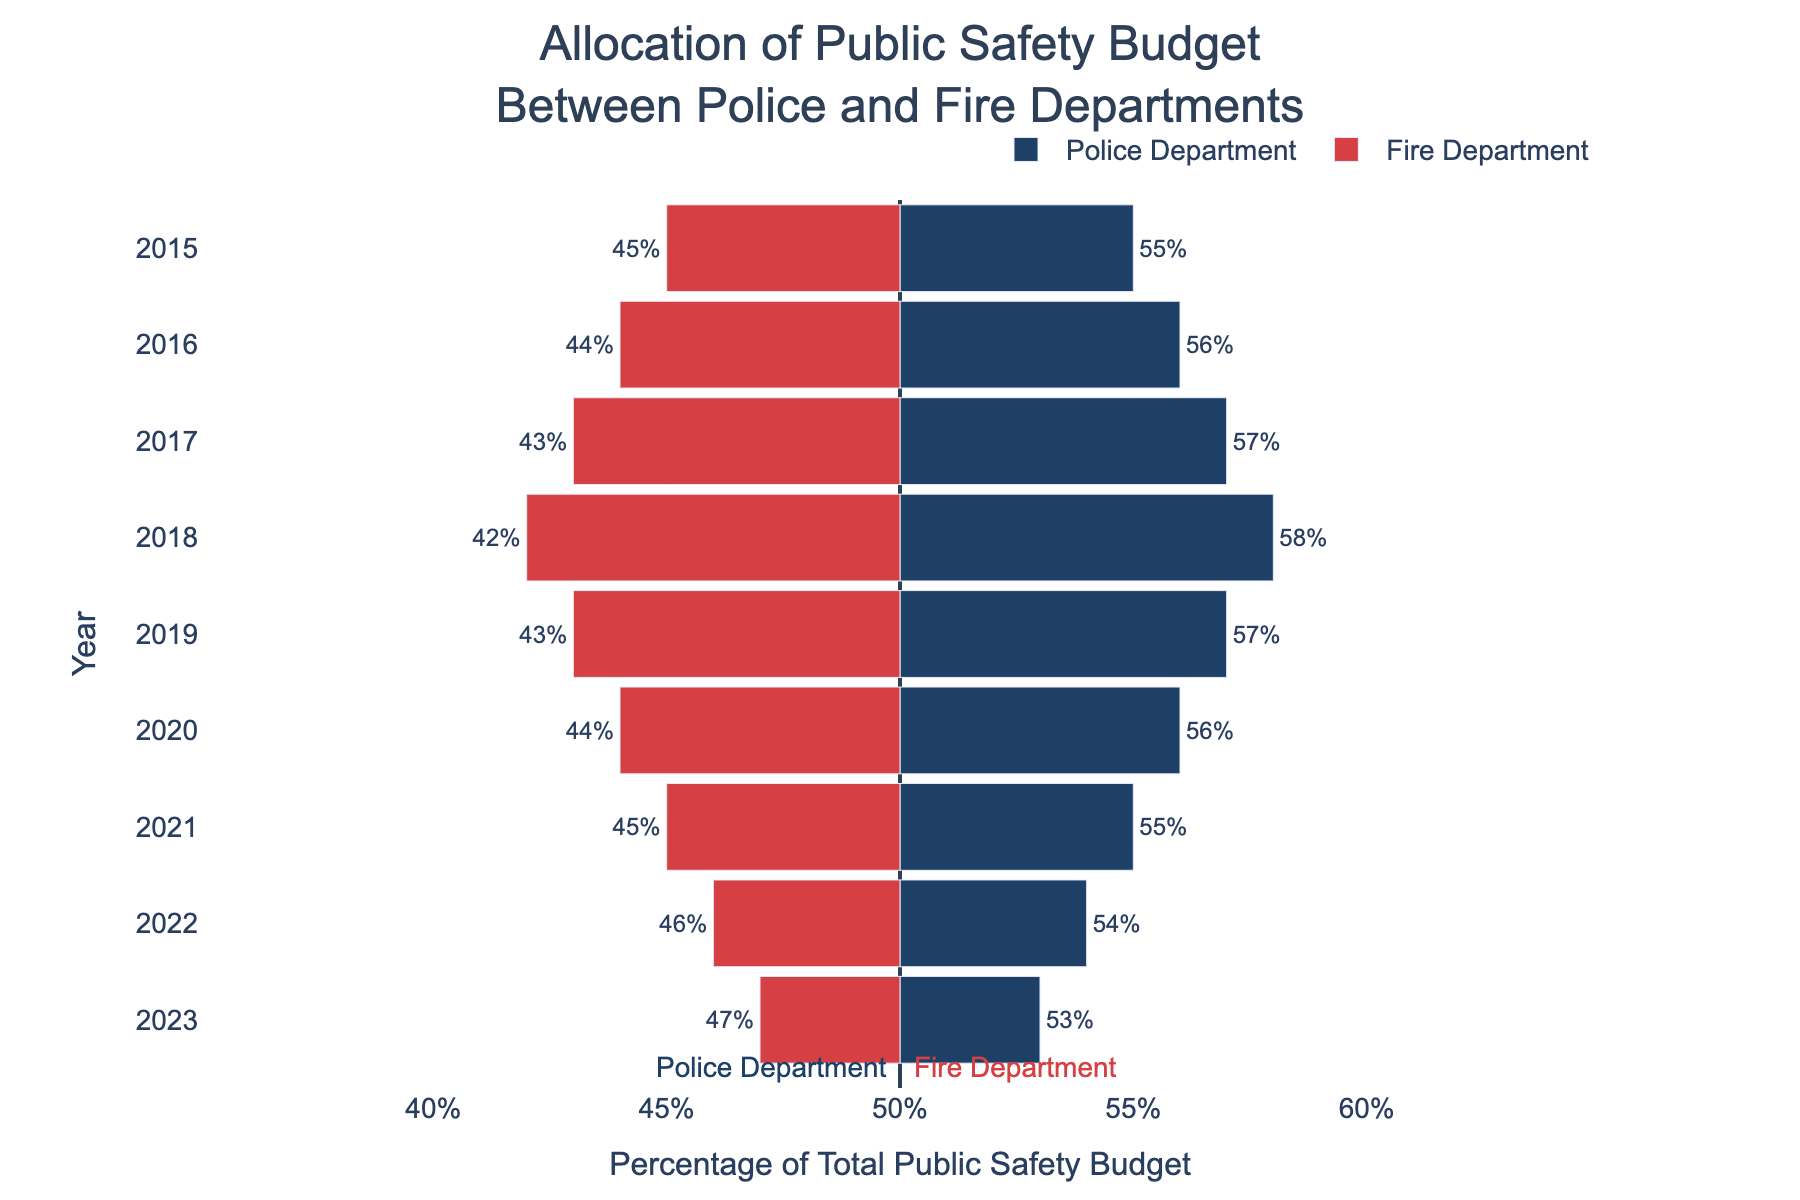When did the Fire Department receive a higher percentage of the public safety budget compared to the Police Department? In the given figure, the Fire Department received a higher percentage of the budget compared to the Police Department in the year 2023. This is indicated by the bar for the Fire Department being higher than the bar for the Police Department.
Answer: 2023 Which department saw the highest budget allocation in 2018? By observing the bars representing the year 2018, we can see that the Police Department's bar is longer than the Fire Department's bar, indicating a higher allocation.
Answer: Police Department What trend can be noticed for the Police Department's budget allocation from 2015 to 2023? From 2015 to 2023, the bars for the Police Department show a decrease in budget allocation. In 2015, the percentage starts at 55% and gradually decreases to 53% in 2023.
Answer: Decreasing trend How does the allocation in 2019 compare to that in 2017 for the Police and Fire Departments? Comparing the bars for 2017 and 2019, the Police Department received the same allocation of 57% in both years, while the Fire Department's allocation remained at 43%.
Answer: Same allocation Calculate the average budget allocation for the Fire Department from 2015 to 2023. To find the average, add the budget allocations for the Fire Department from 2015 (45%) to 2023 (47%), then divide by the number of years (9). The sum is 45 + 44 + 43 + 42 + 43 + 44 + 45 + 46 + 47 = 399. Therefore, the average is 399 / 9 = 44.33%.
Answer: 44.33% Which year showed an equal budget allocation of 55% for both departments? Checking the individual bars from 2015 to 2023, the year 2021 shows a 55% budget allocation for both the Police and Fire Departments.
Answer: 2021 Identify any years where the budget allocation for the Fire Department increased consecutively. Observing the bars, budget allocation for the Fire Department increased consecutively from 2021 (45%) through 2023 (47%).
Answer: 2021 to 2023 What is the difference in the police budget allocation between 2015 and 2023? The allocation for the Police Department was 55% in 2015 and decreased to 53% in 2023. The difference in budget allocation is 55% - 53% = 2%.
Answer: 2% Which department had a consistent budget allocation from 2017 to 2019? By observing the bars for the years 2017 through 2019, we see that the Fire Department's allocation remains consistently at 43% during these years.
Answer: Fire Department What visual clue indicates that 2023 had the highest allocation for the Fire Department within the given years? The bar representing 2023 is visually the longest among all years for the Fire Department, indicating the highest allocation percentage of 47%.
Answer: Longest bar in 2023 